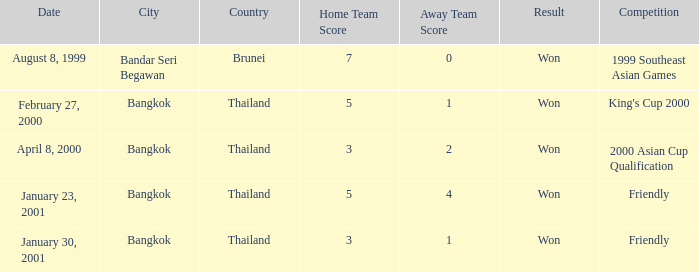What was the result of the game that was played on february 27, 2000? Won. 